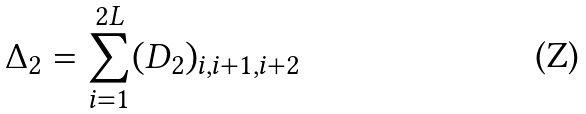Convert formula to latex. <formula><loc_0><loc_0><loc_500><loc_500>\Delta _ { 2 } = \sum _ { i = 1 } ^ { 2 L } ( D _ { 2 } ) _ { i , i + 1 , i + 2 } \,</formula> 